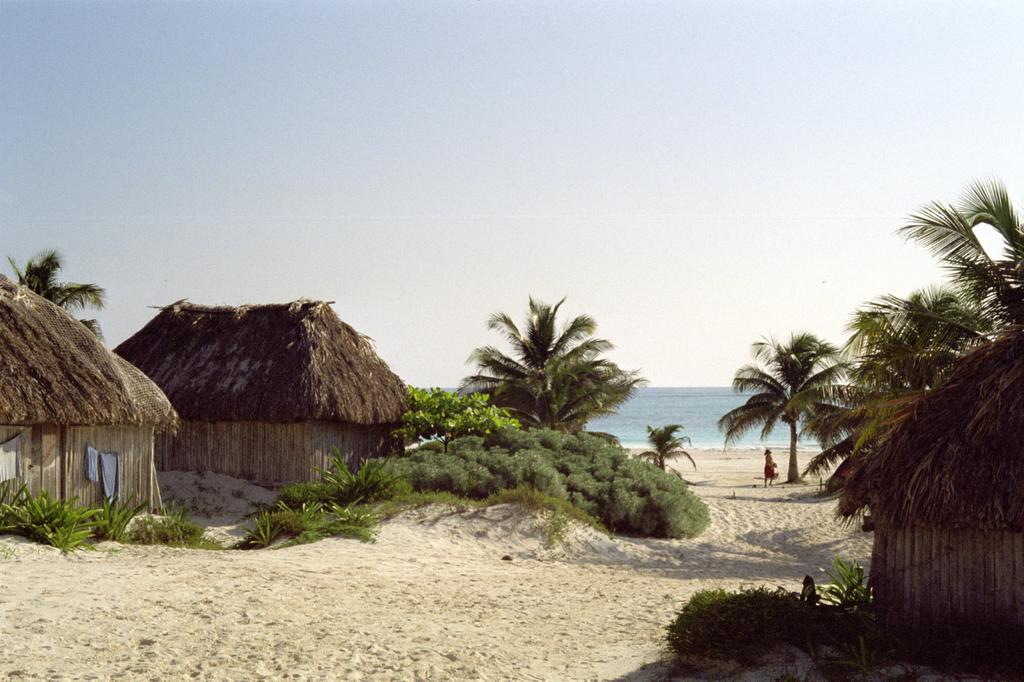What can be seen in the image that resembles a hit? There are a few hits in the image. What type of vegetation is present in the image? There are trees and small plants in the image. Can you describe the woman in the image? There is a woman standing in the background of the image. What is visible in front of the woman? There is water visible in front of the woman. What brand of toothpaste is being used by the squirrel in the image? There is no squirrel present in the image, and therefore no toothpaste usage can be observed. 